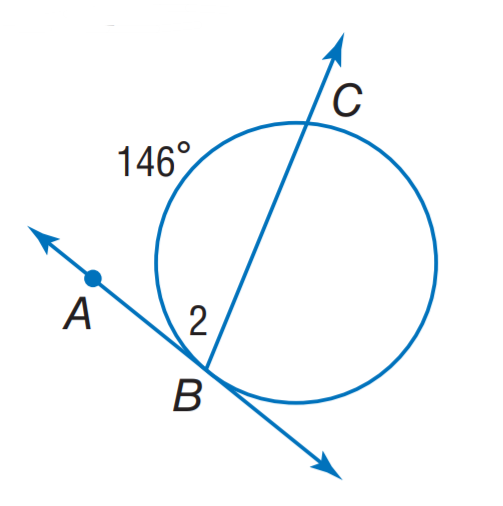Question: Find m \angle 2.
Choices:
A. 73
B. 82
C. 107
D. 146
Answer with the letter. Answer: A 